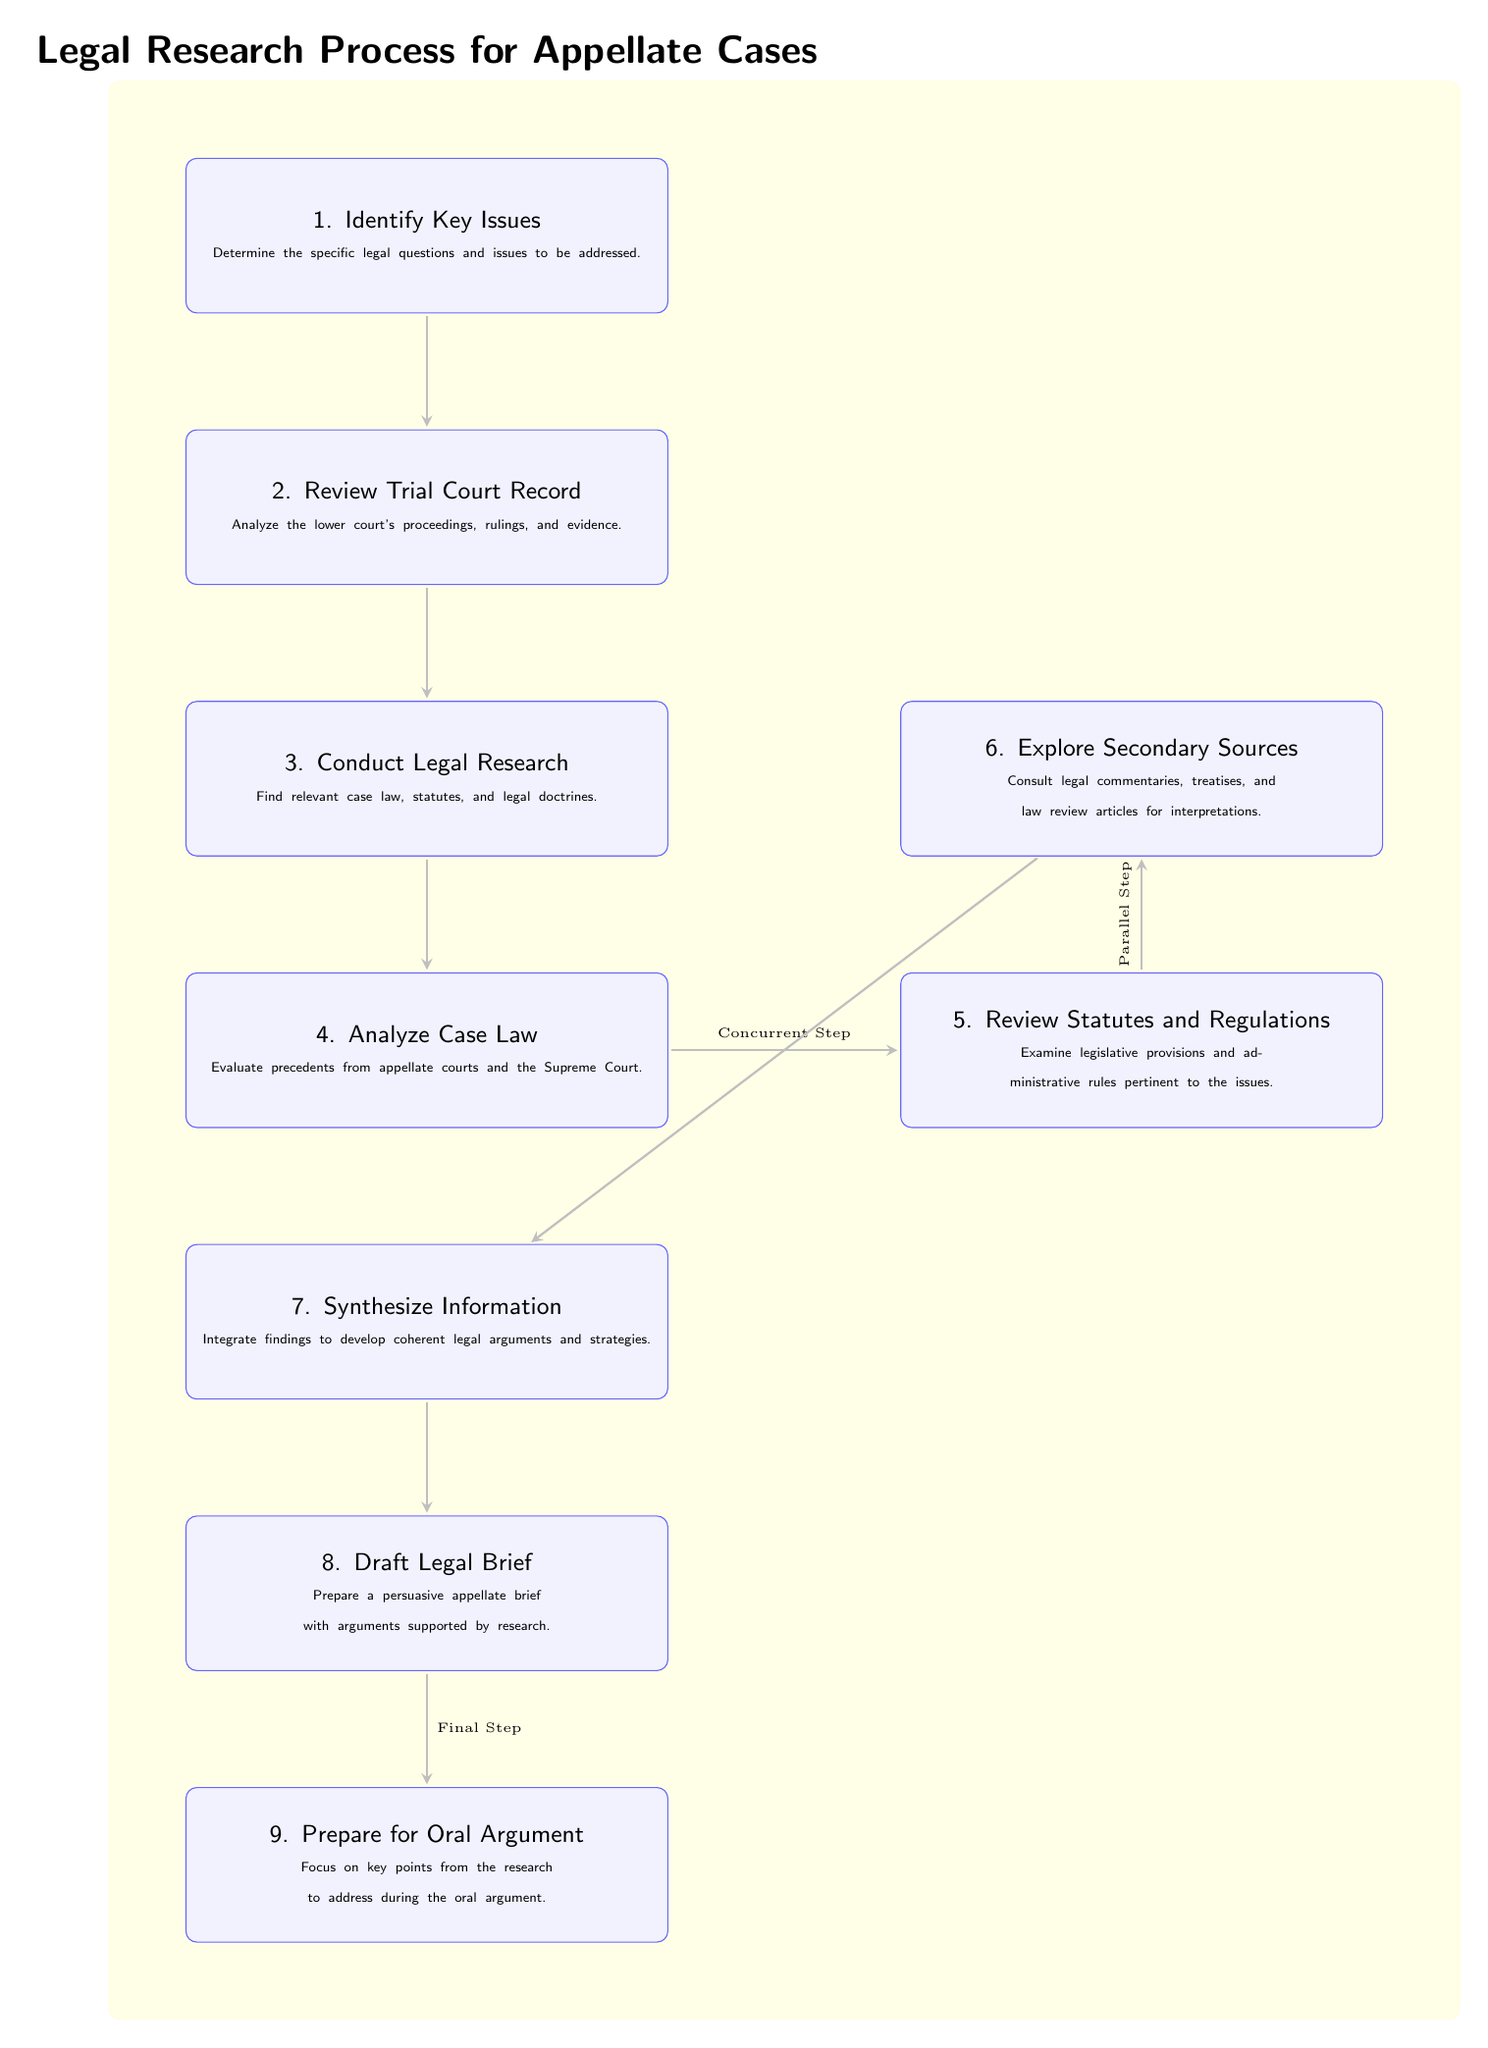What is the first step in the legal research process for appellate cases? According to the diagram, the first step is labeled "1. Identify Key Issues," which involves determining the specific legal questions and issues that need to be addressed.
Answer: Identify Key Issues How many main steps are there in the legal research process as shown in the diagram? The diagram outlines a total of nine main steps in the legal research process, each represented by a node.
Answer: Nine What node follows the "Conduct Legal Research" node? The diagram indicates that "4. Analyze Case Law" is the node that directly follows "3. Conduct Legal Research" in the sequence of steps.
Answer: Analyze Case Law Which steps occur concurrently according to the diagram? The diagram shows that "4. Analyze Case Law" and "5. Review Statutes and Regulations" occur simultaneously, as indicated by the wording "Concurrent Step."
Answer: Analyze Case Law and Review Statutes and Regulations In what step do you synthesize information to develop legal arguments? The diagram specifies that the synthesis of information to develop coherent legal arguments takes place in "7. Synthesize Information."
Answer: Synthesize Information What is the last step in the legal research process for appellate cases? The diagram indicates that the final step in this process is "9. Prepare for Oral Argument," suggesting that all previous research culminates here.
Answer: Prepare for Oral Argument Which nodes are linked by the label "Final Step"? The words "Final Step" connect the "8. Draft Legal Brief" node to the "9. Prepare for Oral Argument" node, indicating the completion of drafting leads to preparations for oral arguments.
Answer: Draft Legal Brief and Prepare for Oral Argument What is the main focus of the "Review Trial Court Record" step? The diagram states that during the "2. Review Trial Court Record" step, the focus is on analyzing the lower court's proceedings, rulings, and evidence.
Answer: Analyzing lower court's proceedings What type of sources can be explored in step 6? Step 6 in the diagram specifically mentions exploring "Secondary Sources," which include legal commentaries, treatises, and law review articles for interpretations.
Answer: Secondary Sources 